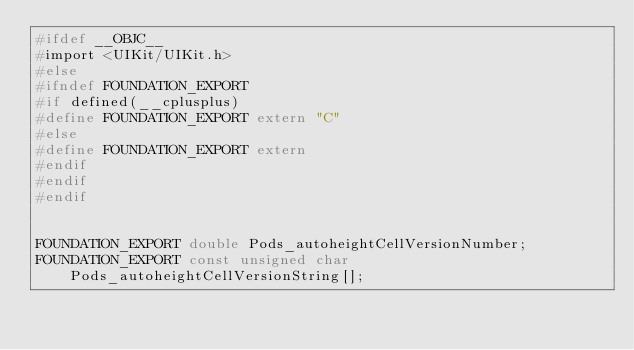Convert code to text. <code><loc_0><loc_0><loc_500><loc_500><_C_>#ifdef __OBJC__
#import <UIKit/UIKit.h>
#else
#ifndef FOUNDATION_EXPORT
#if defined(__cplusplus)
#define FOUNDATION_EXPORT extern "C"
#else
#define FOUNDATION_EXPORT extern
#endif
#endif
#endif


FOUNDATION_EXPORT double Pods_autoheightCellVersionNumber;
FOUNDATION_EXPORT const unsigned char Pods_autoheightCellVersionString[];

</code> 